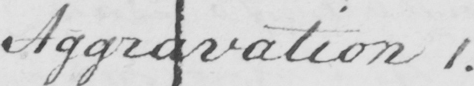Please transcribe the handwritten text in this image. Aggravation 1 . 